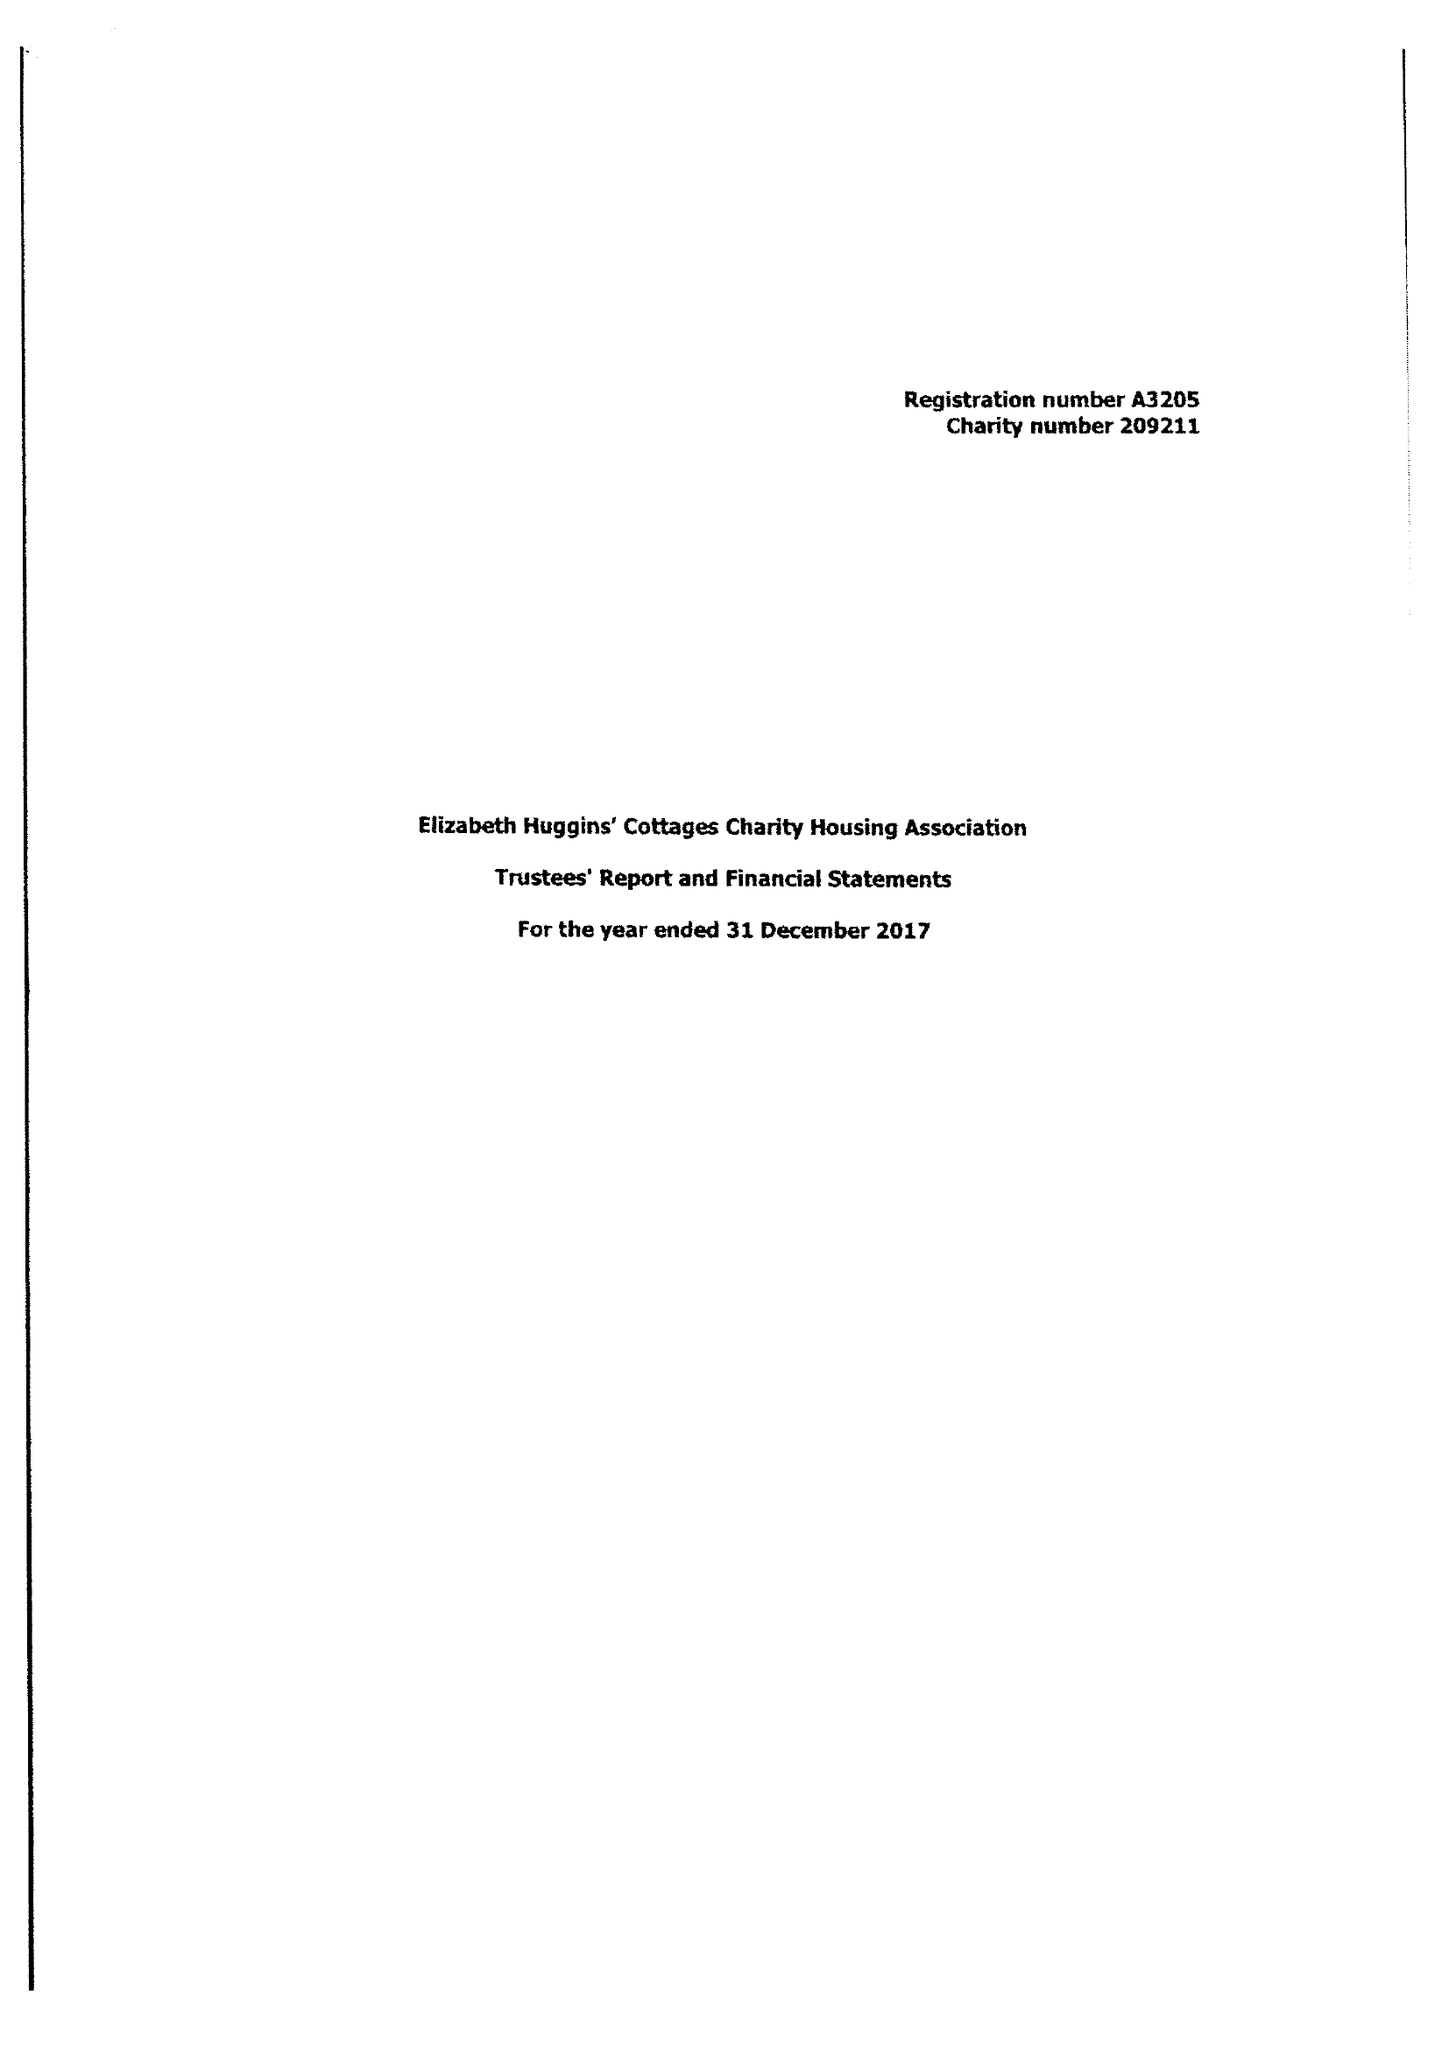What is the value for the spending_annually_in_british_pounds?
Answer the question using a single word or phrase. None 